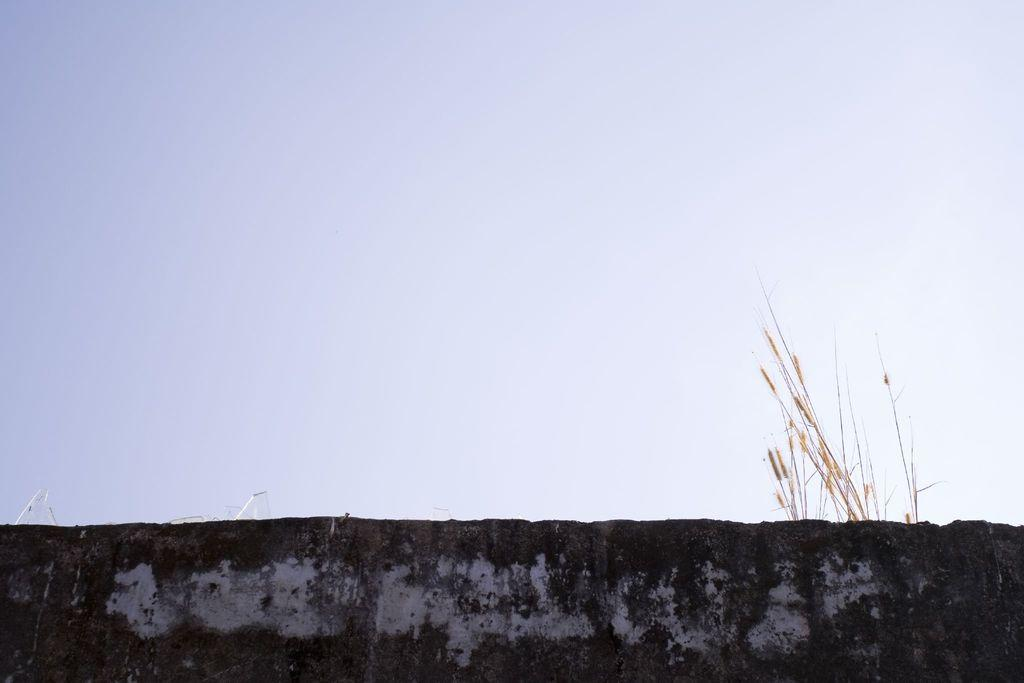What is located at the bottom of the image? There is a wall and a plant at the bottom of the image. What can be seen in the background of the image? The sky is visible at the top of the image. Where is the sink located in the image? There is no sink present in the image. How many men can be seen in the image? There are no men present in the image. 